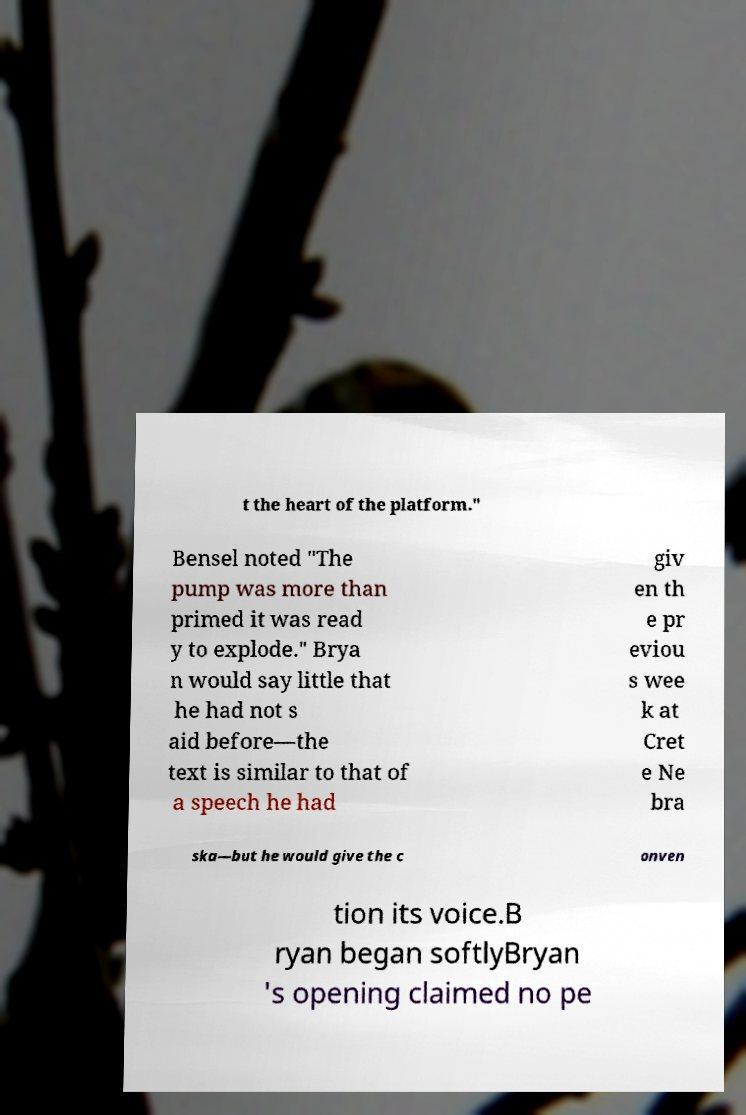Can you read and provide the text displayed in the image?This photo seems to have some interesting text. Can you extract and type it out for me? t the heart of the platform." Bensel noted "The pump was more than primed it was read y to explode." Brya n would say little that he had not s aid before—the text is similar to that of a speech he had giv en th e pr eviou s wee k at Cret e Ne bra ska—but he would give the c onven tion its voice.B ryan began softlyBryan 's opening claimed no pe 